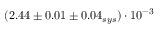<formula> <loc_0><loc_0><loc_500><loc_500>( 2 . 4 4 \pm 0 . 0 1 \pm 0 . 0 4 _ { s y s } ) \cdot 1 0 ^ { - 3 }</formula> 